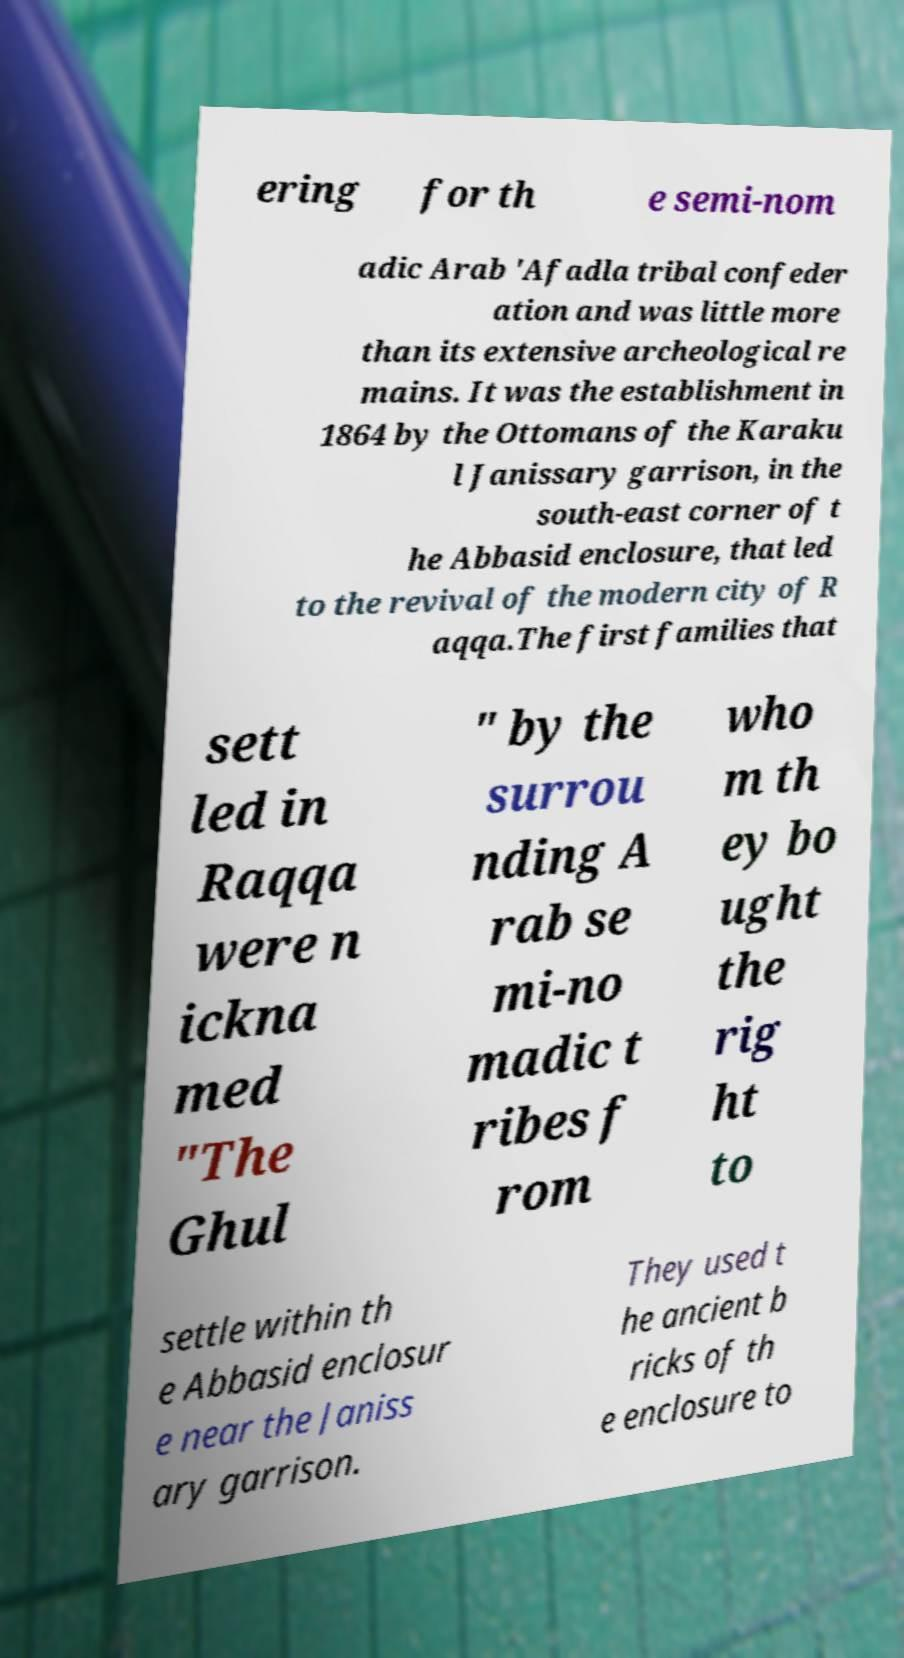Could you extract and type out the text from this image? ering for th e semi-nom adic Arab 'Afadla tribal confeder ation and was little more than its extensive archeological re mains. It was the establishment in 1864 by the Ottomans of the Karaku l Janissary garrison, in the south-east corner of t he Abbasid enclosure, that led to the revival of the modern city of R aqqa.The first families that sett led in Raqqa were n ickna med "The Ghul " by the surrou nding A rab se mi-no madic t ribes f rom who m th ey bo ught the rig ht to settle within th e Abbasid enclosur e near the Janiss ary garrison. They used t he ancient b ricks of th e enclosure to 